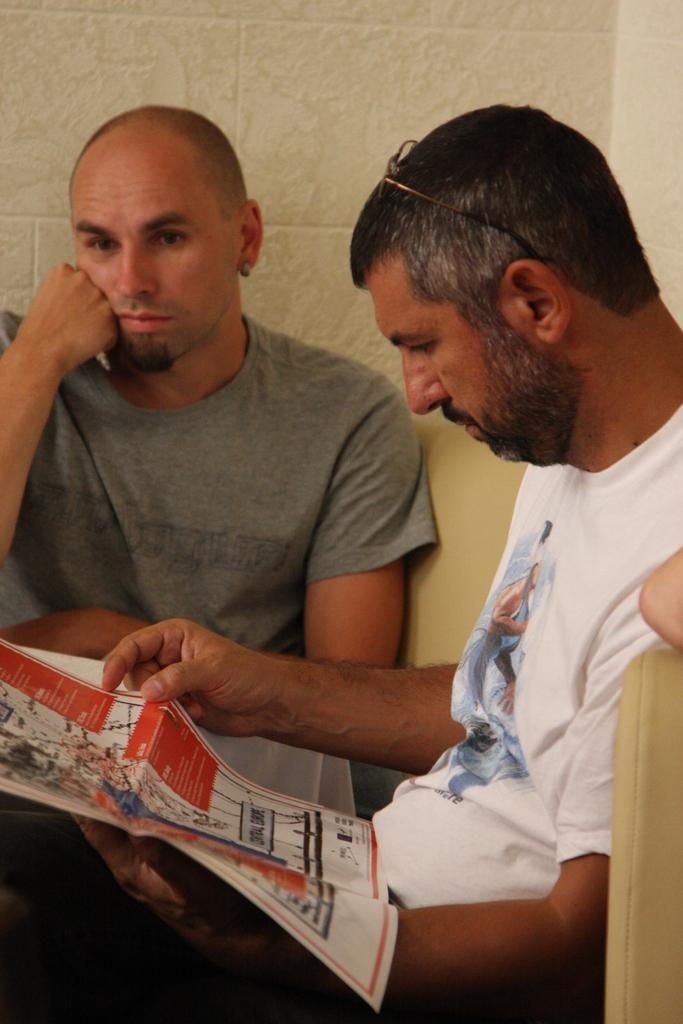What are the people in the image doing? The people in the image are sitting. Can you describe the appearance of one of the people? One of the people is wearing glasses. What is the person wearing glasses holding? The person wearing glasses is holding a paper. What can be seen in the background of the image? There is a wall and an object visible in the background. What type of throat-soothing remedy is being passed around during the feast in the image? There is no feast or throat-soothing remedy present in the image. Who is the manager in the image? There is no mention of a manager or any management-related activities in the image. 